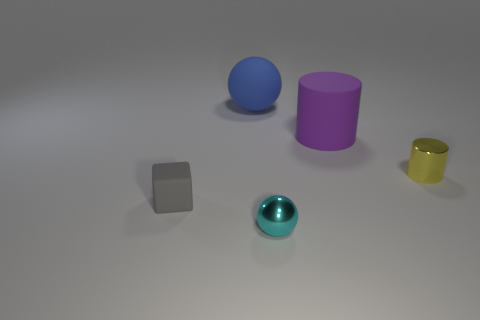Add 3 big blue rubber balls. How many objects exist? 8 Subtract all balls. How many objects are left? 3 Add 3 small yellow metal objects. How many small yellow metal objects are left? 4 Add 3 small gray matte cubes. How many small gray matte cubes exist? 4 Subtract 0 blue blocks. How many objects are left? 5 Subtract all cyan metallic balls. Subtract all tiny yellow metal things. How many objects are left? 3 